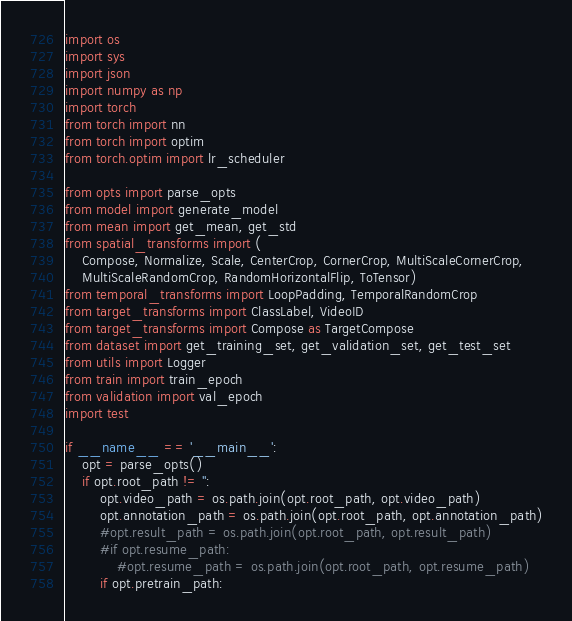Convert code to text. <code><loc_0><loc_0><loc_500><loc_500><_Python_>import os
import sys
import json
import numpy as np
import torch
from torch import nn
from torch import optim
from torch.optim import lr_scheduler

from opts import parse_opts
from model import generate_model
from mean import get_mean, get_std
from spatial_transforms import (
    Compose, Normalize, Scale, CenterCrop, CornerCrop, MultiScaleCornerCrop,
    MultiScaleRandomCrop, RandomHorizontalFlip, ToTensor)
from temporal_transforms import LoopPadding, TemporalRandomCrop
from target_transforms import ClassLabel, VideoID
from target_transforms import Compose as TargetCompose
from dataset import get_training_set, get_validation_set, get_test_set
from utils import Logger
from train import train_epoch
from validation import val_epoch
import test

if __name__ == '__main__':
    opt = parse_opts()
    if opt.root_path != '':
        opt.video_path = os.path.join(opt.root_path, opt.video_path)
        opt.annotation_path = os.path.join(opt.root_path, opt.annotation_path)
        #opt.result_path = os.path.join(opt.root_path, opt.result_path)
        #if opt.resume_path:
            #opt.resume_path = os.path.join(opt.root_path, opt.resume_path)
        if opt.pretrain_path:</code> 